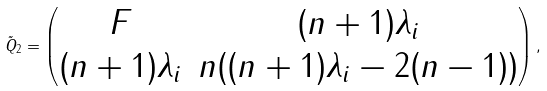Convert formula to latex. <formula><loc_0><loc_0><loc_500><loc_500>\tilde { Q } _ { 2 } = \begin{pmatrix} F & ( n + 1 ) \lambda _ { i } \\ ( n + 1 ) \lambda _ { i } & n ( ( n + 1 ) \lambda _ { i } - 2 ( n - 1 ) ) \end{pmatrix} ,</formula> 